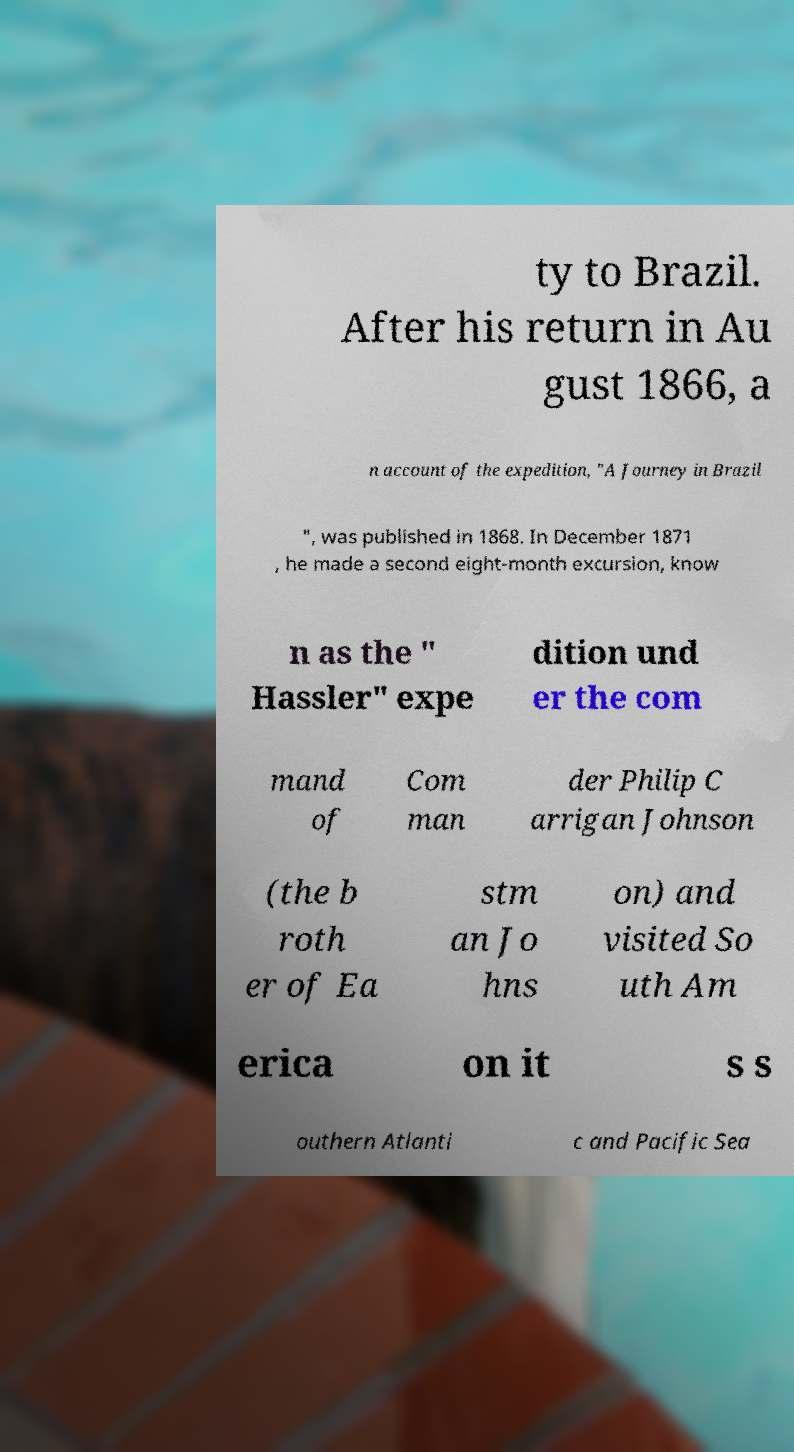Can you read and provide the text displayed in the image?This photo seems to have some interesting text. Can you extract and type it out for me? ty to Brazil. After his return in Au gust 1866, a n account of the expedition, "A Journey in Brazil ", was published in 1868. In December 1871 , he made a second eight-month excursion, know n as the " Hassler" expe dition und er the com mand of Com man der Philip C arrigan Johnson (the b roth er of Ea stm an Jo hns on) and visited So uth Am erica on it s s outhern Atlanti c and Pacific Sea 